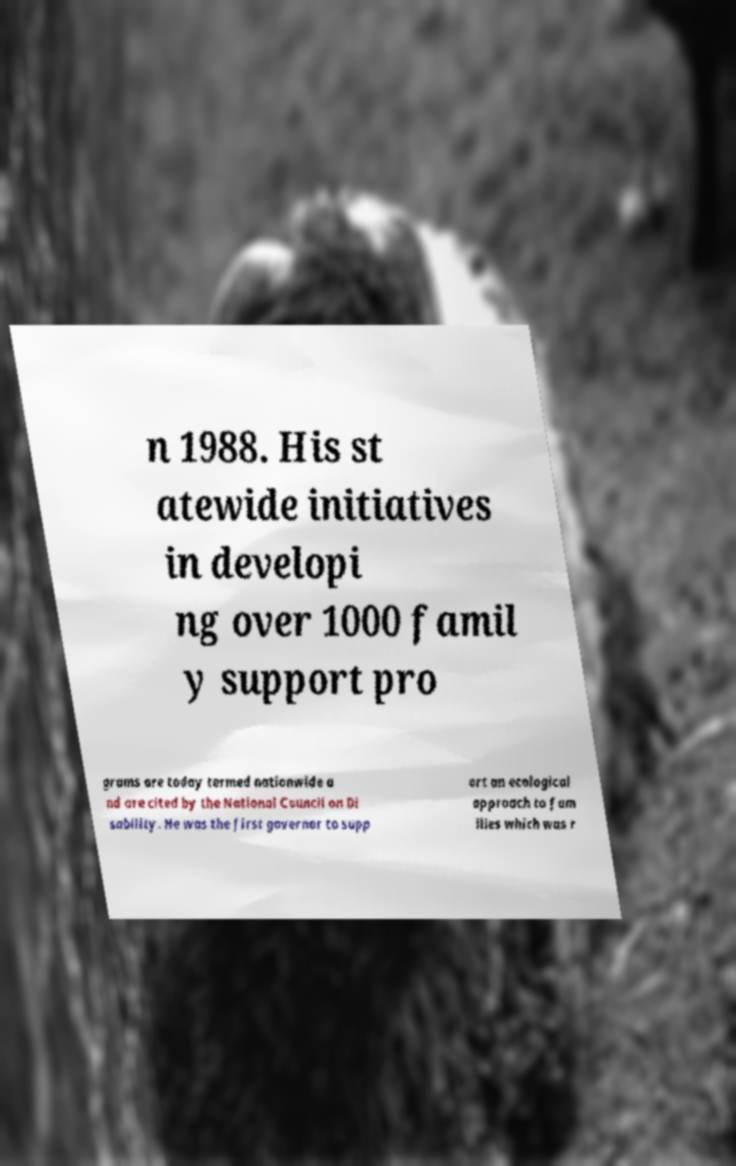Could you assist in decoding the text presented in this image and type it out clearly? n 1988. His st atewide initiatives in developi ng over 1000 famil y support pro grams are today termed nationwide a nd are cited by the National Council on Di sability. He was the first governor to supp ort an ecological approach to fam ilies which was r 